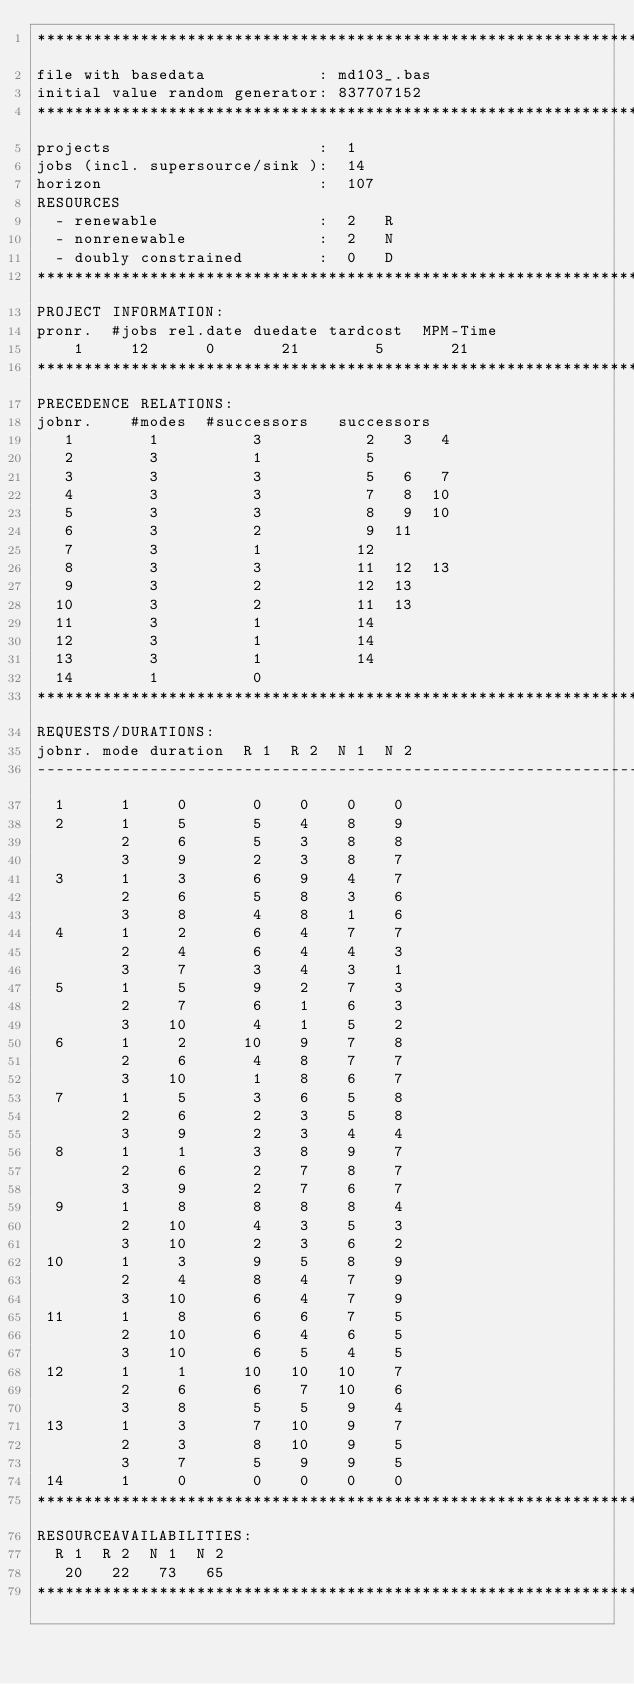Convert code to text. <code><loc_0><loc_0><loc_500><loc_500><_ObjectiveC_>************************************************************************
file with basedata            : md103_.bas
initial value random generator: 837707152
************************************************************************
projects                      :  1
jobs (incl. supersource/sink ):  14
horizon                       :  107
RESOURCES
  - renewable                 :  2   R
  - nonrenewable              :  2   N
  - doubly constrained        :  0   D
************************************************************************
PROJECT INFORMATION:
pronr.  #jobs rel.date duedate tardcost  MPM-Time
    1     12      0       21        5       21
************************************************************************
PRECEDENCE RELATIONS:
jobnr.    #modes  #successors   successors
   1        1          3           2   3   4
   2        3          1           5
   3        3          3           5   6   7
   4        3          3           7   8  10
   5        3          3           8   9  10
   6        3          2           9  11
   7        3          1          12
   8        3          3          11  12  13
   9        3          2          12  13
  10        3          2          11  13
  11        3          1          14
  12        3          1          14
  13        3          1          14
  14        1          0        
************************************************************************
REQUESTS/DURATIONS:
jobnr. mode duration  R 1  R 2  N 1  N 2
------------------------------------------------------------------------
  1      1     0       0    0    0    0
  2      1     5       5    4    8    9
         2     6       5    3    8    8
         3     9       2    3    8    7
  3      1     3       6    9    4    7
         2     6       5    8    3    6
         3     8       4    8    1    6
  4      1     2       6    4    7    7
         2     4       6    4    4    3
         3     7       3    4    3    1
  5      1     5       9    2    7    3
         2     7       6    1    6    3
         3    10       4    1    5    2
  6      1     2      10    9    7    8
         2     6       4    8    7    7
         3    10       1    8    6    7
  7      1     5       3    6    5    8
         2     6       2    3    5    8
         3     9       2    3    4    4
  8      1     1       3    8    9    7
         2     6       2    7    8    7
         3     9       2    7    6    7
  9      1     8       8    8    8    4
         2    10       4    3    5    3
         3    10       2    3    6    2
 10      1     3       9    5    8    9
         2     4       8    4    7    9
         3    10       6    4    7    9
 11      1     8       6    6    7    5
         2    10       6    4    6    5
         3    10       6    5    4    5
 12      1     1      10   10   10    7
         2     6       6    7   10    6
         3     8       5    5    9    4
 13      1     3       7   10    9    7
         2     3       8   10    9    5
         3     7       5    9    9    5
 14      1     0       0    0    0    0
************************************************************************
RESOURCEAVAILABILITIES:
  R 1  R 2  N 1  N 2
   20   22   73   65
************************************************************************
</code> 